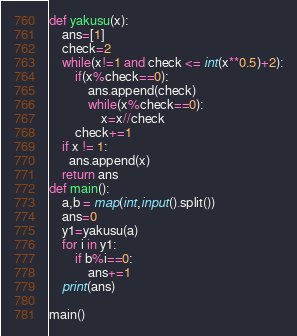Convert code to text. <code><loc_0><loc_0><loc_500><loc_500><_Python_>def yakusu(x):
    ans=[1]
    check=2
    while(x!=1 and check <= int(x**0.5)+2):
        if(x%check==0):
            ans.append(check)
            while(x%check==0):
                x=x//check
        check+=1
    if x != 1:
      ans.append(x)
    return ans
def main():
    a,b = map(int,input().split())	
    ans=0
    y1=yakusu(a)
    for i in y1:
        if b%i==0:
            ans+=1
    print(ans)
 
main()</code> 